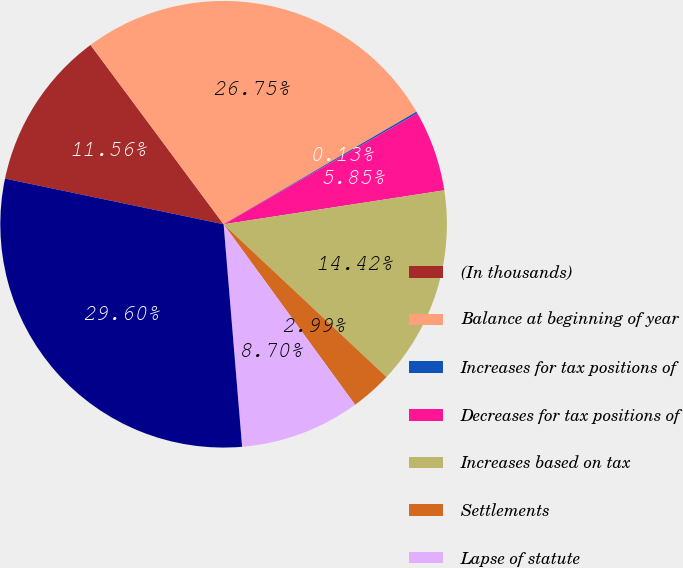Convert chart. <chart><loc_0><loc_0><loc_500><loc_500><pie_chart><fcel>(In thousands)<fcel>Balance at beginning of year<fcel>Increases for tax positions of<fcel>Decreases for tax positions of<fcel>Increases based on tax<fcel>Settlements<fcel>Lapse of statute<fcel>Balance at end of year<nl><fcel>11.56%<fcel>26.75%<fcel>0.13%<fcel>5.85%<fcel>14.42%<fcel>2.99%<fcel>8.7%<fcel>29.6%<nl></chart> 